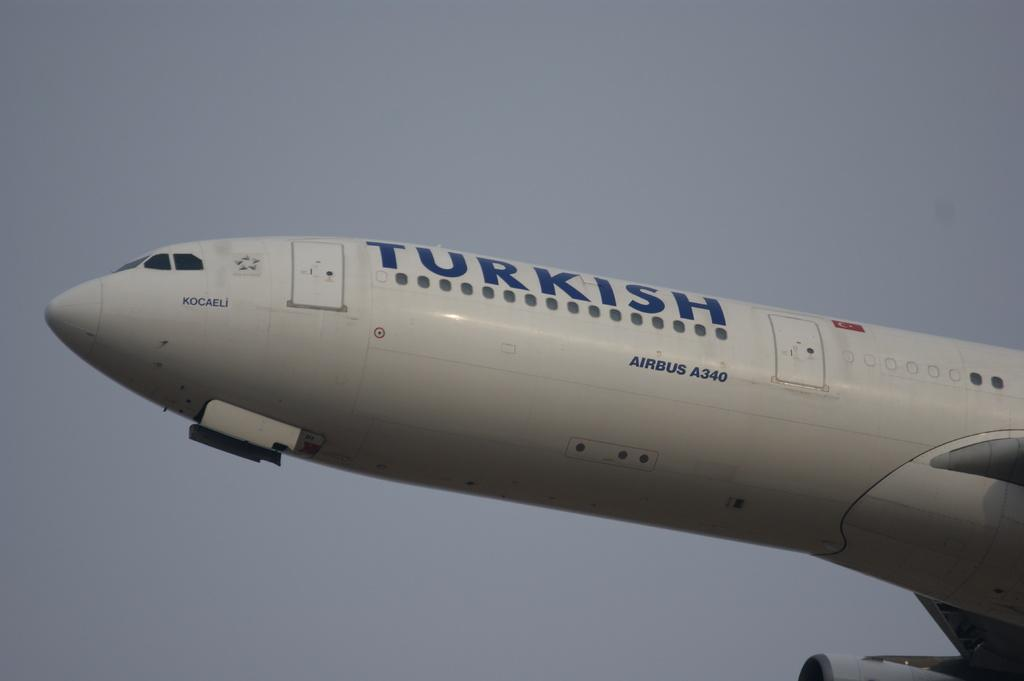<image>
Describe the image concisely. A Turkish airbus A340 is getting ready for takeoff. 